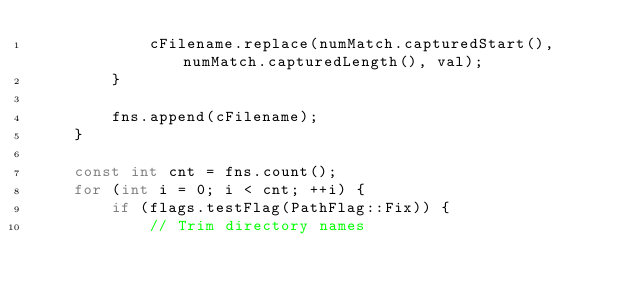<code> <loc_0><loc_0><loc_500><loc_500><_C++_>			cFilename.replace(numMatch.capturedStart(), numMatch.capturedLength(), val);
		}

		fns.append(cFilename);
	}

	const int cnt = fns.count();
	for (int i = 0; i < cnt; ++i) {
		if (flags.testFlag(PathFlag::Fix)) {
			// Trim directory names</code> 